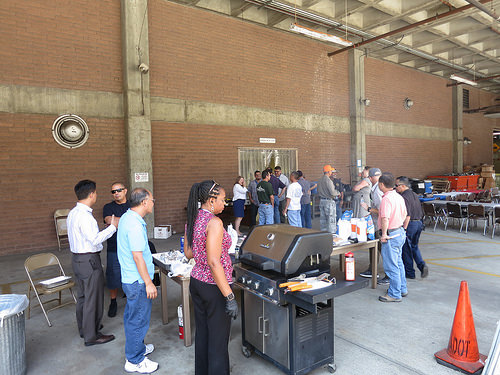<image>
Is there a man on the chair? No. The man is not positioned on the chair. They may be near each other, but the man is not supported by or resting on top of the chair. 